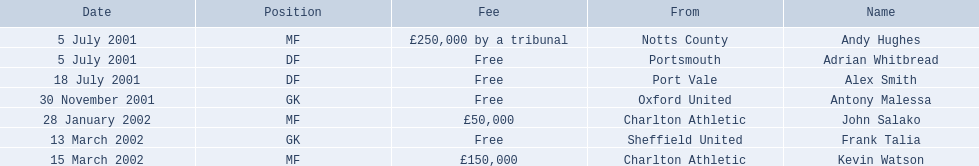Who are all the players? Andy Hughes, Adrian Whitbread, Alex Smith, Antony Malessa, John Salako, Frank Talia, Kevin Watson. What were their fees? £250,000 by a tribunal, Free, Free, Free, £50,000, Free, £150,000. And how much was kevin watson's fee? £150,000. 